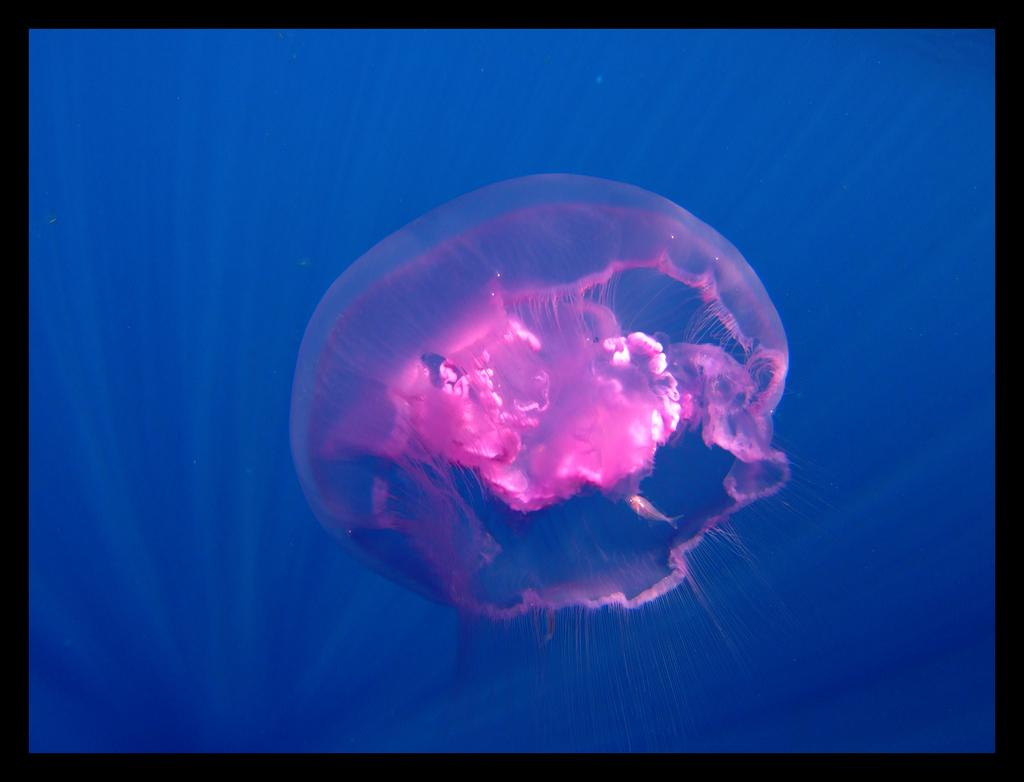What type of sea creature is in the image? There is a jellyfish in the image. What color is the jellyfish? The jellyfish is pink in color. What type of drink is the jellyfish holding in the image? There is no drink present in the image, as jellyfish do not have the ability to hold objects. 